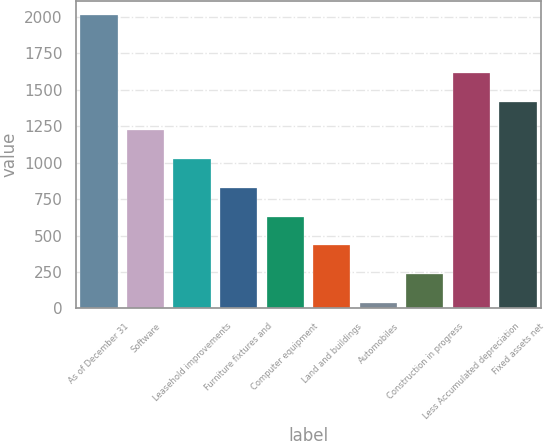<chart> <loc_0><loc_0><loc_500><loc_500><bar_chart><fcel>As of December 31<fcel>Software<fcel>Leasehold improvements<fcel>Furniture fixtures and<fcel>Computer equipment<fcel>Land and buildings<fcel>Automobiles<fcel>Construction in progress<fcel>Less Accumulated depreciation<fcel>Fixed assets net<nl><fcel>2010<fcel>1221.6<fcel>1024.5<fcel>827.4<fcel>630.3<fcel>433.2<fcel>39<fcel>236.1<fcel>1615.8<fcel>1418.7<nl></chart> 